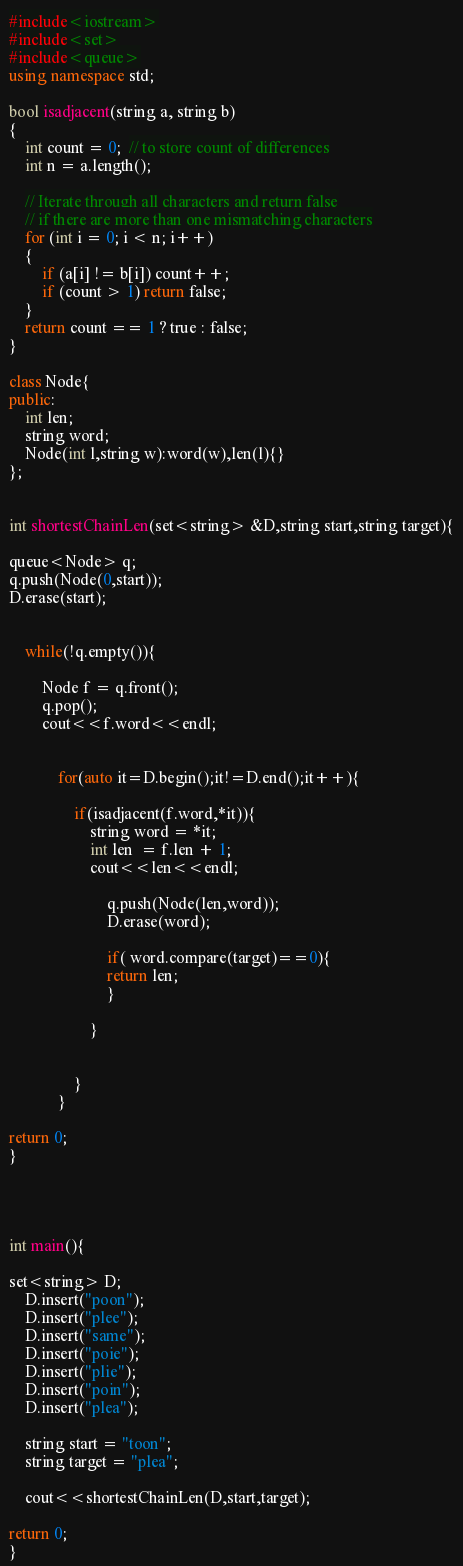Convert code to text. <code><loc_0><loc_0><loc_500><loc_500><_C++_>#include<iostream>
#include<set>
#include<queue>
using namespace std;

bool isadjacent(string a, string b)
{
    int count = 0;  // to store count of differences
    int n = a.length();

    // Iterate through all characters and return false
    // if there are more than one mismatching characters
    for (int i = 0; i < n; i++)
    {
        if (a[i] != b[i]) count++;
        if (count > 1) return false;
    }
    return count == 1 ? true : false;
}

class Node{
public:
    int len;
    string word;
    Node(int l,string w):word(w),len(l){}
};


int shortestChainLen(set<string> &D,string start,string target){

queue<Node> q;
q.push(Node(0,start));
D.erase(start);


    while(!q.empty()){

        Node f = q.front();
        q.pop();
        cout<<f.word<<endl;


            for(auto it=D.begin();it!=D.end();it++){

                if(isadjacent(f.word,*it)){
                    string word = *it;
                    int len  = f.len + 1;
                    cout<<len<<endl;

                        q.push(Node(len,word));
                        D.erase(word);

                        if( word.compare(target)==0){
                        return len;
                        }

                    }


                }
            }

return 0;
}




int main(){

set<string> D;
    D.insert("poon");
    D.insert("plee");
    D.insert("same");
    D.insert("poie");
    D.insert("plie");
    D.insert("poin");
    D.insert("plea");

    string start = "toon";
    string target = "plea";

    cout<<shortestChainLen(D,start,target);

return 0;
}
</code> 